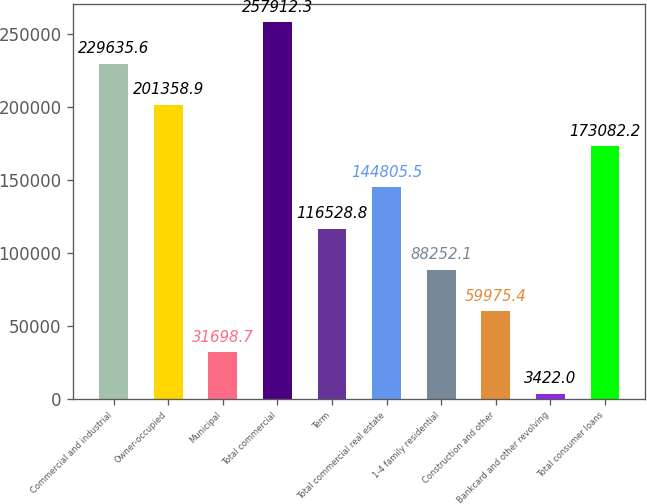Convert chart to OTSL. <chart><loc_0><loc_0><loc_500><loc_500><bar_chart><fcel>Commercial and industrial<fcel>Owner-occupied<fcel>Municipal<fcel>Total commercial<fcel>Term<fcel>Total commercial real estate<fcel>1-4 family residential<fcel>Construction and other<fcel>Bankcard and other revolving<fcel>Total consumer loans<nl><fcel>229636<fcel>201359<fcel>31698.7<fcel>257912<fcel>116529<fcel>144806<fcel>88252.1<fcel>59975.4<fcel>3422<fcel>173082<nl></chart> 